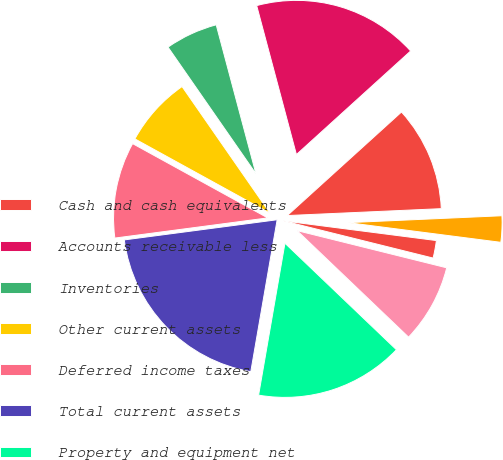Convert chart to OTSL. <chart><loc_0><loc_0><loc_500><loc_500><pie_chart><fcel>Cash and cash equivalents<fcel>Accounts receivable less<fcel>Inventories<fcel>Other current assets<fcel>Deferred income taxes<fcel>Total current assets<fcel>Property and equipment net<fcel>Amortizable intangibles net<fcel>Investments in third-party<fcel>Other long-term assets<nl><fcel>11.01%<fcel>17.43%<fcel>5.51%<fcel>7.34%<fcel>10.09%<fcel>20.18%<fcel>15.6%<fcel>8.26%<fcel>1.84%<fcel>2.75%<nl></chart> 